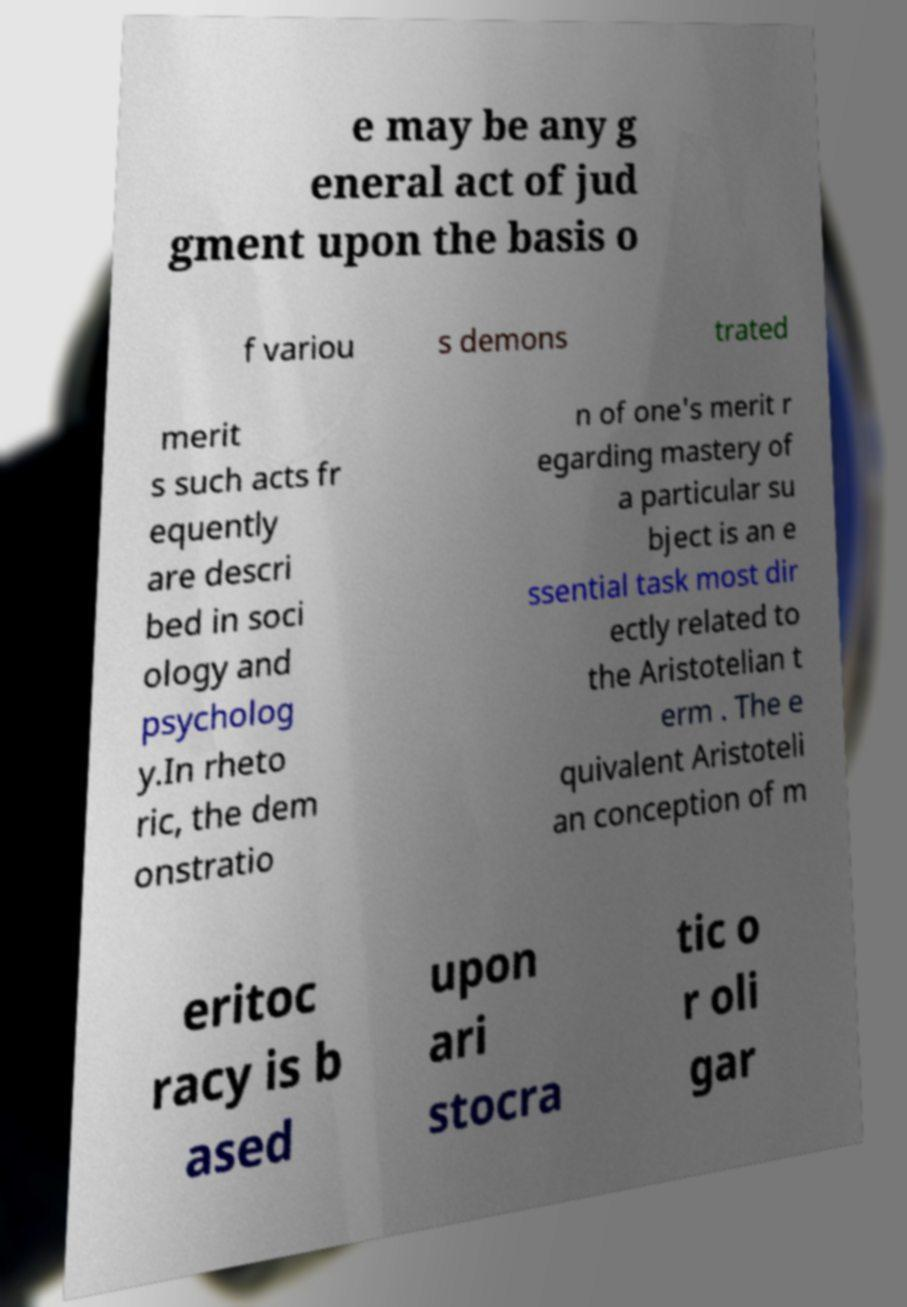Can you read and provide the text displayed in the image?This photo seems to have some interesting text. Can you extract and type it out for me? e may be any g eneral act of jud gment upon the basis o f variou s demons trated merit s such acts fr equently are descri bed in soci ology and psycholog y.In rheto ric, the dem onstratio n of one's merit r egarding mastery of a particular su bject is an e ssential task most dir ectly related to the Aristotelian t erm . The e quivalent Aristoteli an conception of m eritoc racy is b ased upon ari stocra tic o r oli gar 